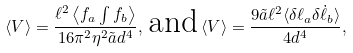Convert formula to latex. <formula><loc_0><loc_0><loc_500><loc_500>\langle V \rangle = \frac { \ell ^ { 2 } \left \langle f _ { a } \int f _ { b } \right \rangle } { 1 6 \pi ^ { 2 } \eta ^ { 2 } \tilde { a } d ^ { 4 } } , \, \text {and} \, \langle V \rangle = \frac { 9 \tilde { a } \ell ^ { 2 } \langle \delta \ell _ { a } \delta \dot { \ell } _ { b } \rangle } { 4 d ^ { 4 } } ,</formula> 